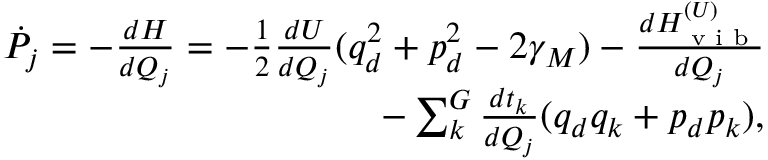<formula> <loc_0><loc_0><loc_500><loc_500>\begin{array} { r } { \dot { P } _ { j } = - \frac { d H } { d Q _ { j } } = - \frac { 1 } { 2 } \frac { d U } { d Q _ { j } } ( q _ { d } ^ { 2 } + p _ { d } ^ { 2 } - 2 \gamma _ { M } ) - \frac { d H _ { v i b } ^ { ( U ) } } { d Q _ { j } } } \\ { - \sum _ { k } ^ { G } \frac { d t _ { k } } { d Q _ { j } } ( q _ { d } q _ { k } + p _ { d } p _ { k } ) , } \end{array}</formula> 